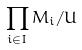<formula> <loc_0><loc_0><loc_500><loc_500>\prod _ { i \in I } M _ { i } / U</formula> 